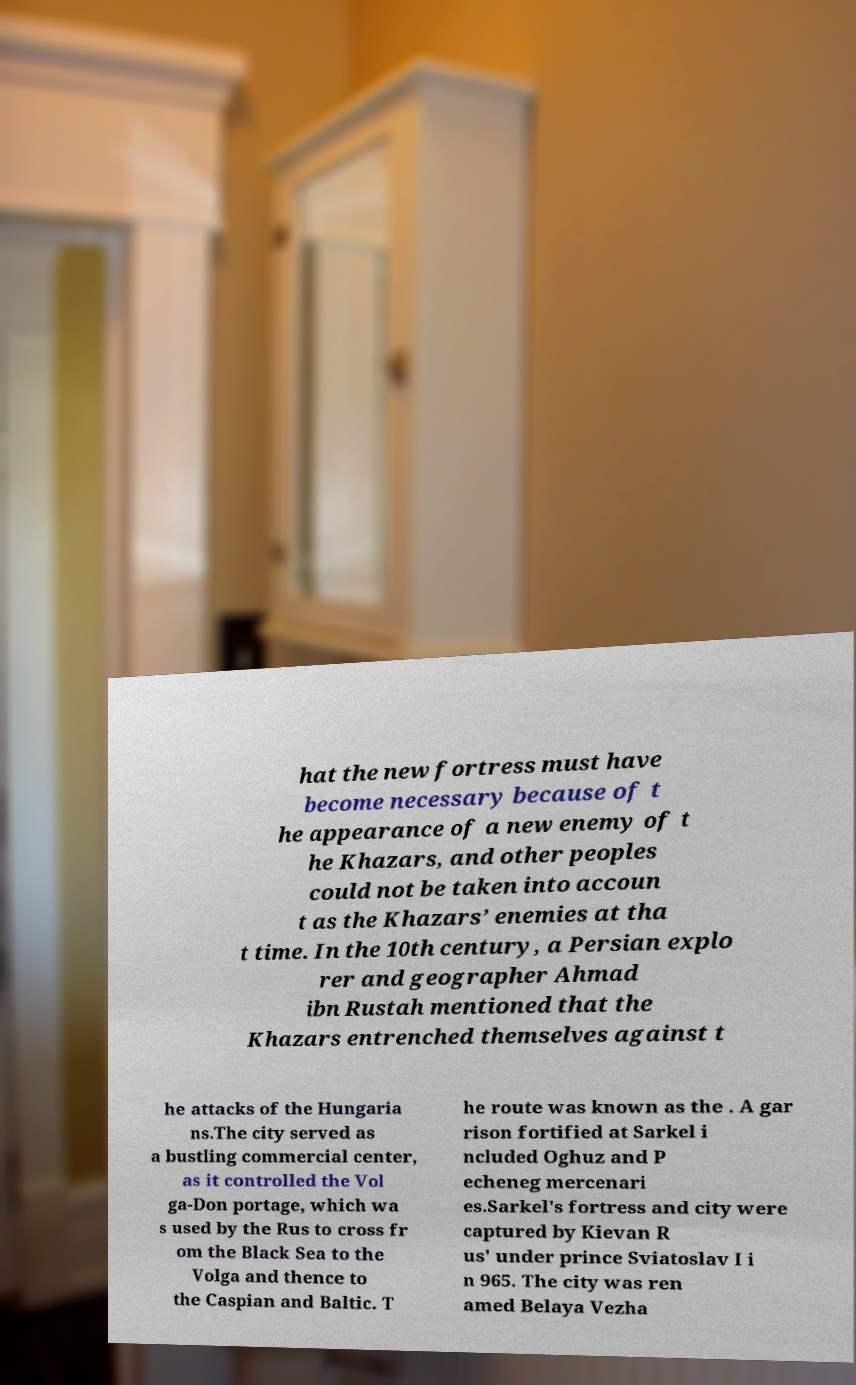Please read and relay the text visible in this image. What does it say? hat the new fortress must have become necessary because of t he appearance of a new enemy of t he Khazars, and other peoples could not be taken into accoun t as the Khazars’ enemies at tha t time. In the 10th century, a Persian explo rer and geographer Ahmad ibn Rustah mentioned that the Khazars entrenched themselves against t he attacks of the Hungaria ns.The city served as a bustling commercial center, as it controlled the Vol ga-Don portage, which wa s used by the Rus to cross fr om the Black Sea to the Volga and thence to the Caspian and Baltic. T he route was known as the . A gar rison fortified at Sarkel i ncluded Oghuz and P echeneg mercenari es.Sarkel's fortress and city were captured by Kievan R us' under prince Sviatoslav I i n 965. The city was ren amed Belaya Vezha 